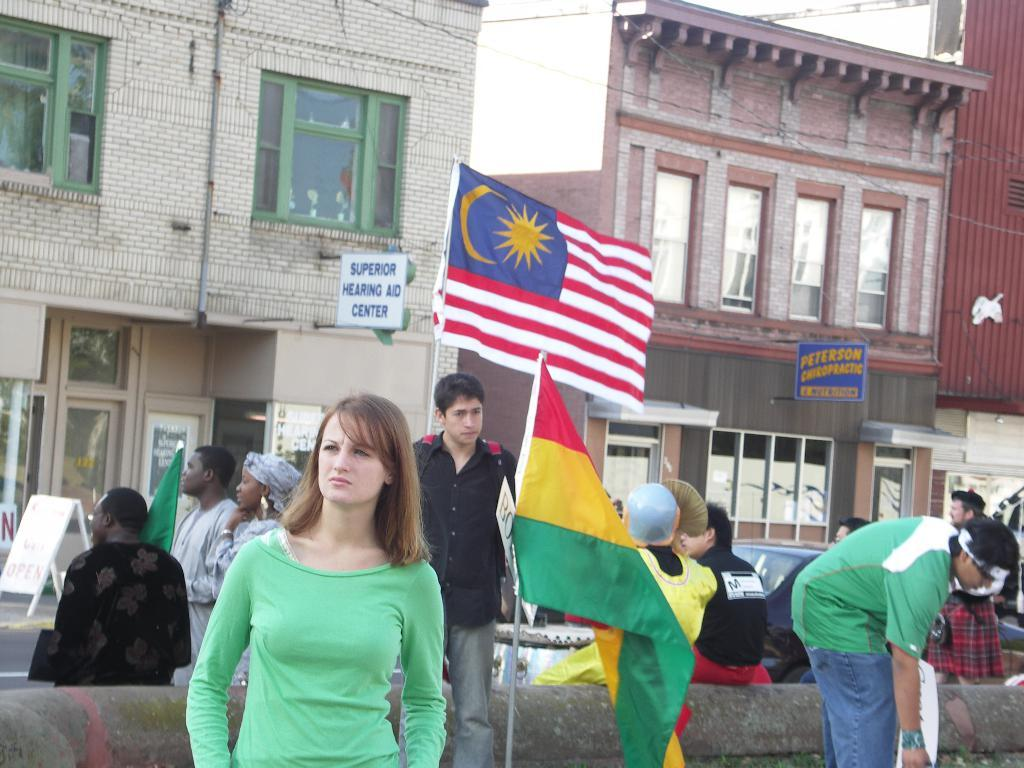What is the main subject in the center of the image? There are persons in the center of the image. What additional element can be seen in the image? There is a flag in the image. What can be observed in the background of the image? There are buildings in the background of the image. What type of wine is being served at the event in the image? There is no indication of any wine or event in the image; it only features persons, a flag, and buildings in the background. 